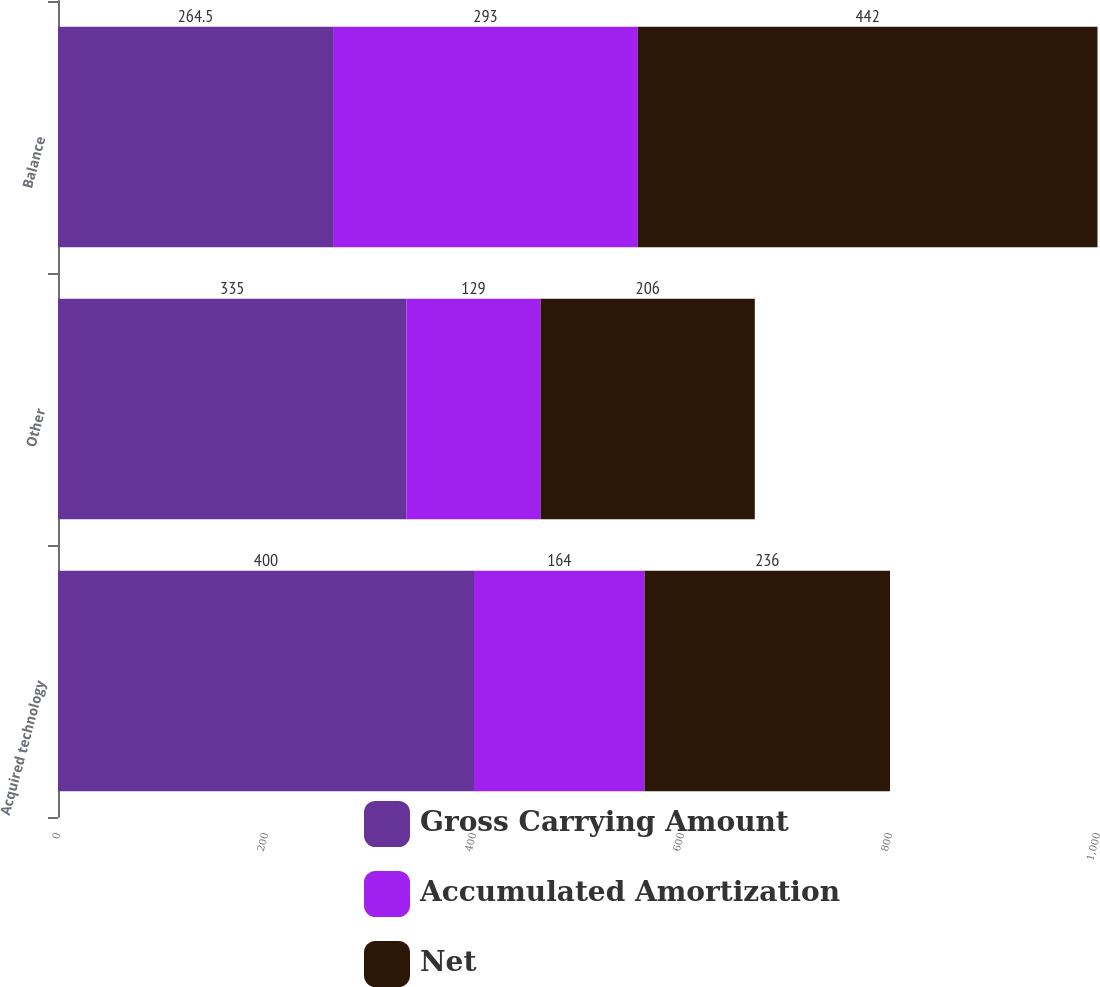<chart> <loc_0><loc_0><loc_500><loc_500><stacked_bar_chart><ecel><fcel>Acquired technology<fcel>Other<fcel>Balance<nl><fcel>Gross Carrying Amount<fcel>400<fcel>335<fcel>264.5<nl><fcel>Accumulated Amortization<fcel>164<fcel>129<fcel>293<nl><fcel>Net<fcel>236<fcel>206<fcel>442<nl></chart> 